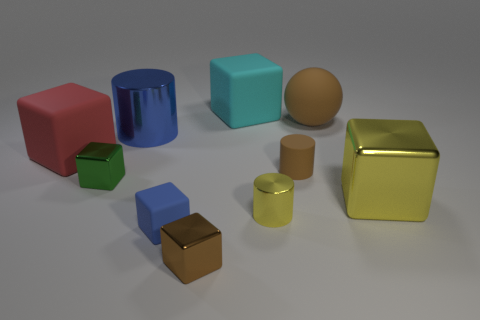Subtract 3 cubes. How many cubes are left? 3 Subtract all yellow blocks. How many blocks are left? 5 Subtract all large yellow metal cubes. How many cubes are left? 5 Subtract all gray blocks. Subtract all brown cylinders. How many blocks are left? 6 Subtract all cylinders. How many objects are left? 7 Subtract all shiny cylinders. Subtract all brown rubber objects. How many objects are left? 6 Add 4 cyan rubber things. How many cyan rubber things are left? 5 Add 9 big yellow blocks. How many big yellow blocks exist? 10 Subtract 0 gray cubes. How many objects are left? 10 